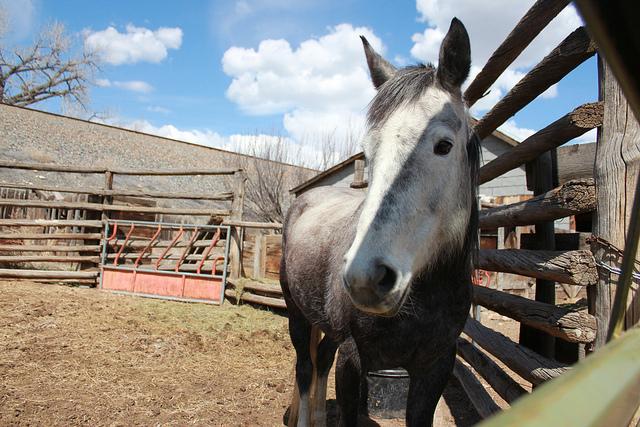Is there a shadow in the image?
Quick response, please. Yes. What color is the gate?
Concise answer only. Brown. Does this horse have a marking on his forehead?
Be succinct. Yes. What color are the trees?
Short answer required. Brown. 